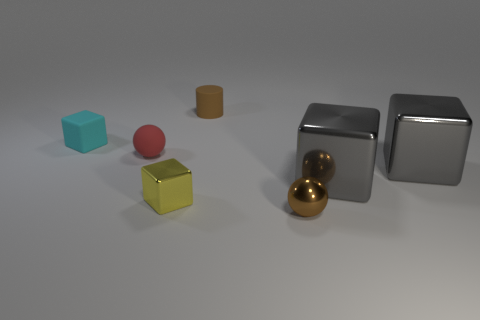The other tiny thing that is the same shape as the tiny cyan matte object is what color?
Provide a short and direct response. Yellow. Is there any other thing that has the same shape as the small yellow metal thing?
Make the answer very short. Yes. The tiny metal thing that is left of the brown matte thing has what shape?
Make the answer very short. Cube. What number of tiny cyan things are the same shape as the small yellow metal object?
Offer a terse response. 1. There is a small cube behind the red sphere; does it have the same color as the shiny thing that is in front of the yellow thing?
Offer a very short reply. No. What number of things are yellow metallic things or small cyan rubber cubes?
Your response must be concise. 2. How many tiny yellow cubes are the same material as the cyan cube?
Ensure brevity in your answer.  0. Are there fewer red matte cylinders than cyan things?
Your answer should be very brief. Yes. Is the material of the ball to the left of the small brown ball the same as the brown ball?
Your response must be concise. No. What number of balls are tiny brown rubber things or cyan matte things?
Provide a short and direct response. 0. 